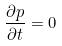<formula> <loc_0><loc_0><loc_500><loc_500>\frac { \partial p } { \partial t } = 0</formula> 